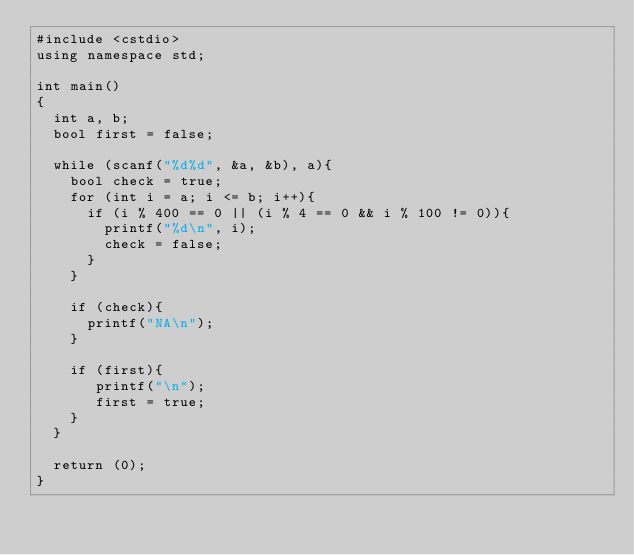<code> <loc_0><loc_0><loc_500><loc_500><_C++_>#include <cstdio>
using namespace std;

int main()
{
	int a, b;
	bool first = false;

	while (scanf("%d%d", &a, &b), a){
		bool check = true;
		for (int i = a; i <= b; i++){
			if (i % 400 == 0 || (i % 4 == 0 && i % 100 != 0)){
				printf("%d\n", i);
				check = false;
			}
		}

		if (check){
			printf("NA\n");
		}

		if (first){
		   printf("\n");		
		   first = true;
		}
	}

	return (0);
}</code> 